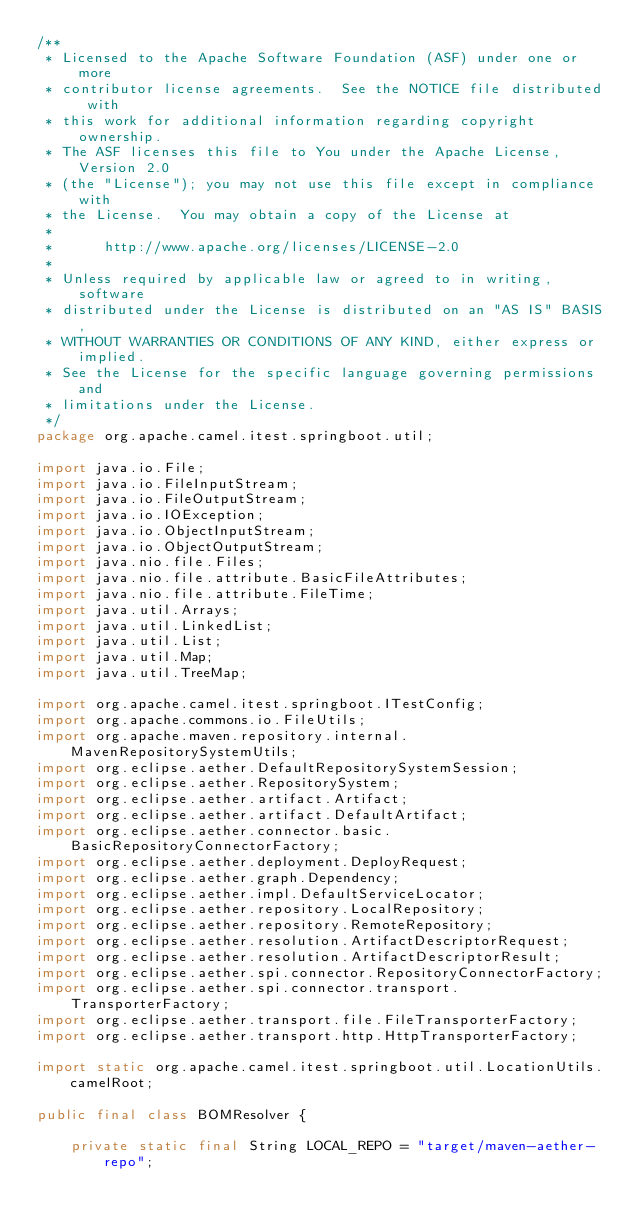<code> <loc_0><loc_0><loc_500><loc_500><_Java_>/**
 * Licensed to the Apache Software Foundation (ASF) under one or more
 * contributor license agreements.  See the NOTICE file distributed with
 * this work for additional information regarding copyright ownership.
 * The ASF licenses this file to You under the Apache License, Version 2.0
 * (the "License"); you may not use this file except in compliance with
 * the License.  You may obtain a copy of the License at
 *
 *      http://www.apache.org/licenses/LICENSE-2.0
 *
 * Unless required by applicable law or agreed to in writing, software
 * distributed under the License is distributed on an "AS IS" BASIS,
 * WITHOUT WARRANTIES OR CONDITIONS OF ANY KIND, either express or implied.
 * See the License for the specific language governing permissions and
 * limitations under the License.
 */
package org.apache.camel.itest.springboot.util;

import java.io.File;
import java.io.FileInputStream;
import java.io.FileOutputStream;
import java.io.IOException;
import java.io.ObjectInputStream;
import java.io.ObjectOutputStream;
import java.nio.file.Files;
import java.nio.file.attribute.BasicFileAttributes;
import java.nio.file.attribute.FileTime;
import java.util.Arrays;
import java.util.LinkedList;
import java.util.List;
import java.util.Map;
import java.util.TreeMap;

import org.apache.camel.itest.springboot.ITestConfig;
import org.apache.commons.io.FileUtils;
import org.apache.maven.repository.internal.MavenRepositorySystemUtils;
import org.eclipse.aether.DefaultRepositorySystemSession;
import org.eclipse.aether.RepositorySystem;
import org.eclipse.aether.artifact.Artifact;
import org.eclipse.aether.artifact.DefaultArtifact;
import org.eclipse.aether.connector.basic.BasicRepositoryConnectorFactory;
import org.eclipse.aether.deployment.DeployRequest;
import org.eclipse.aether.graph.Dependency;
import org.eclipse.aether.impl.DefaultServiceLocator;
import org.eclipse.aether.repository.LocalRepository;
import org.eclipse.aether.repository.RemoteRepository;
import org.eclipse.aether.resolution.ArtifactDescriptorRequest;
import org.eclipse.aether.resolution.ArtifactDescriptorResult;
import org.eclipse.aether.spi.connector.RepositoryConnectorFactory;
import org.eclipse.aether.spi.connector.transport.TransporterFactory;
import org.eclipse.aether.transport.file.FileTransporterFactory;
import org.eclipse.aether.transport.http.HttpTransporterFactory;

import static org.apache.camel.itest.springboot.util.LocationUtils.camelRoot;

public final class BOMResolver {

    private static final String LOCAL_REPO = "target/maven-aether-repo";
</code> 